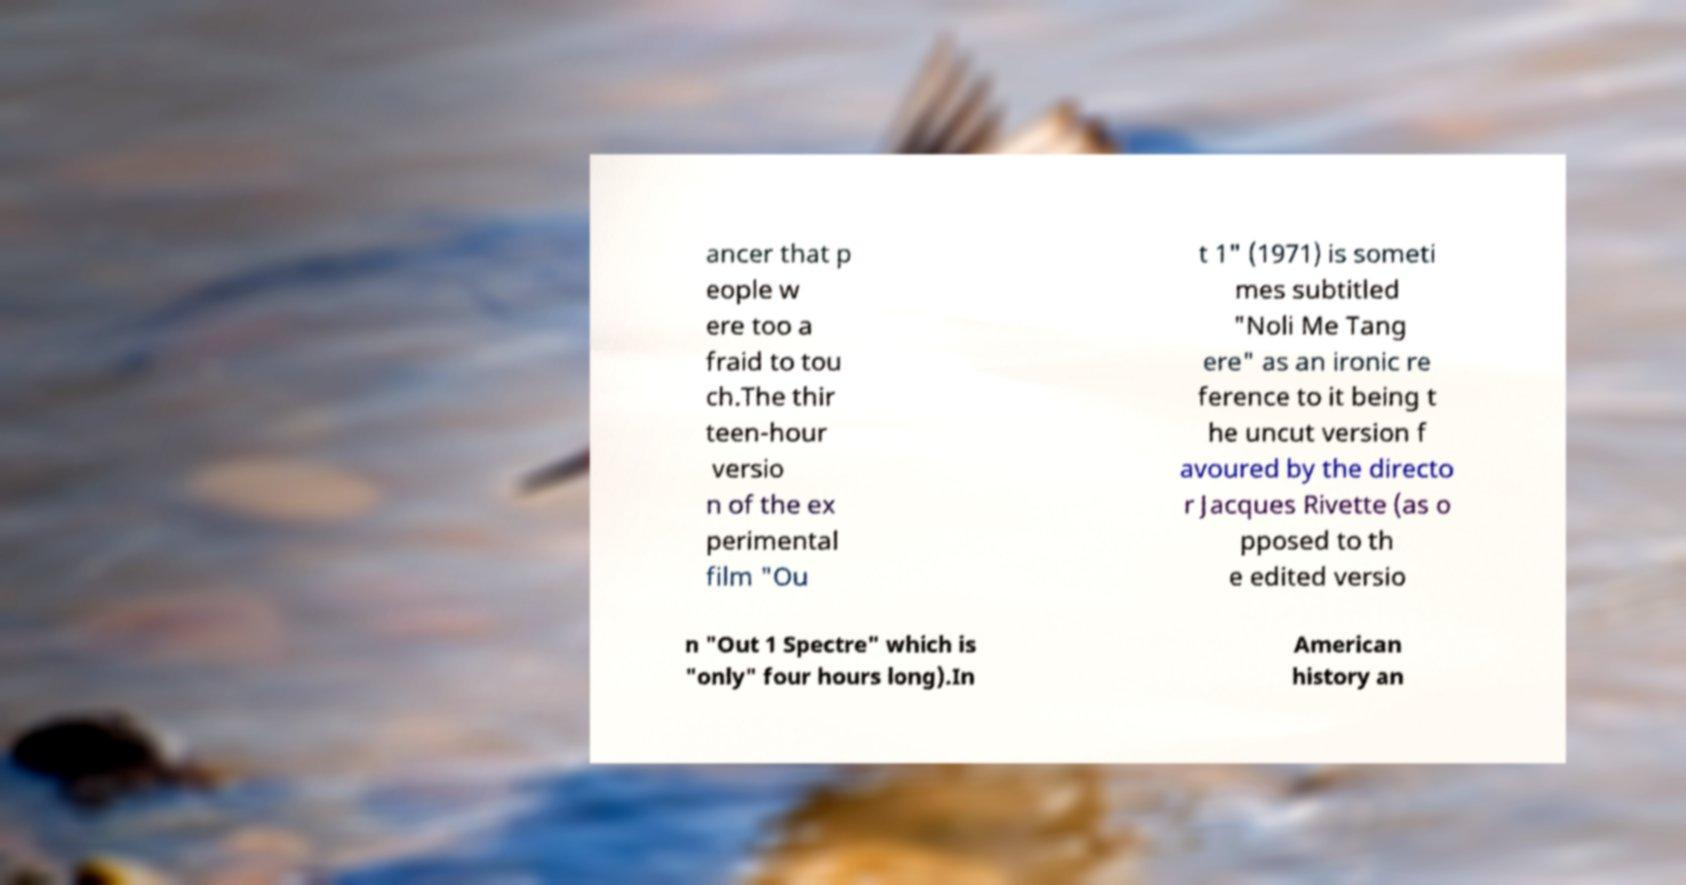Could you extract and type out the text from this image? ancer that p eople w ere too a fraid to tou ch.The thir teen-hour versio n of the ex perimental film "Ou t 1" (1971) is someti mes subtitled "Noli Me Tang ere" as an ironic re ference to it being t he uncut version f avoured by the directo r Jacques Rivette (as o pposed to th e edited versio n "Out 1 Spectre" which is "only" four hours long).In American history an 